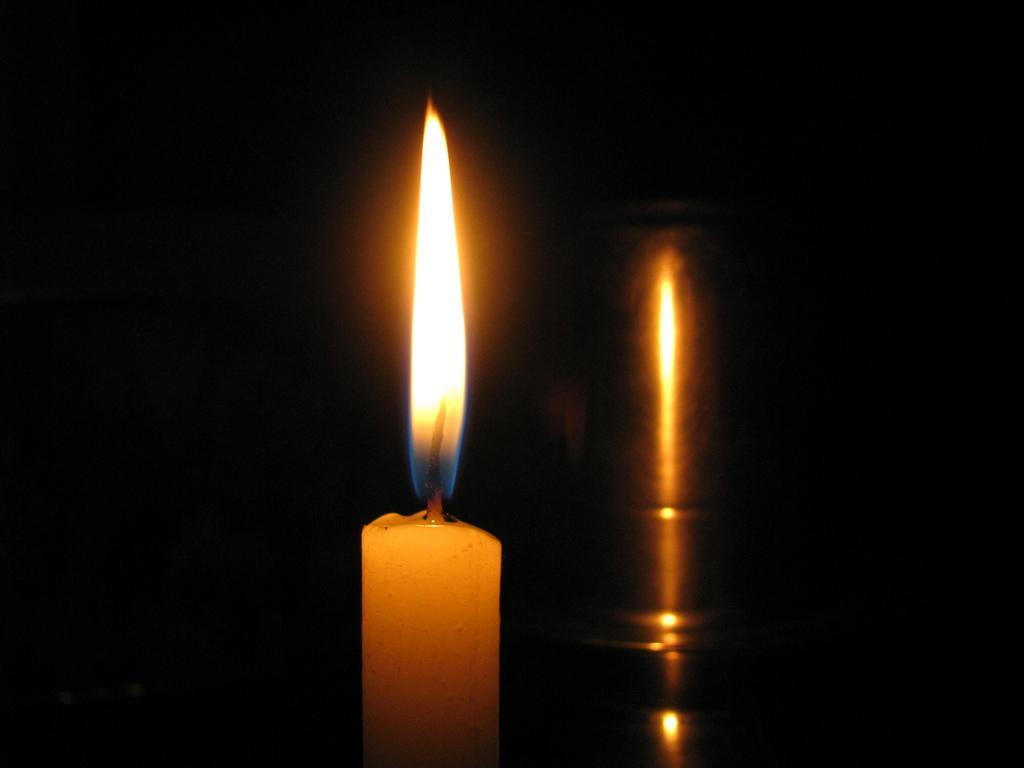Can you describe this image briefly? In the picture we can see a candle and a light to it and beside it we can see a image of it. 